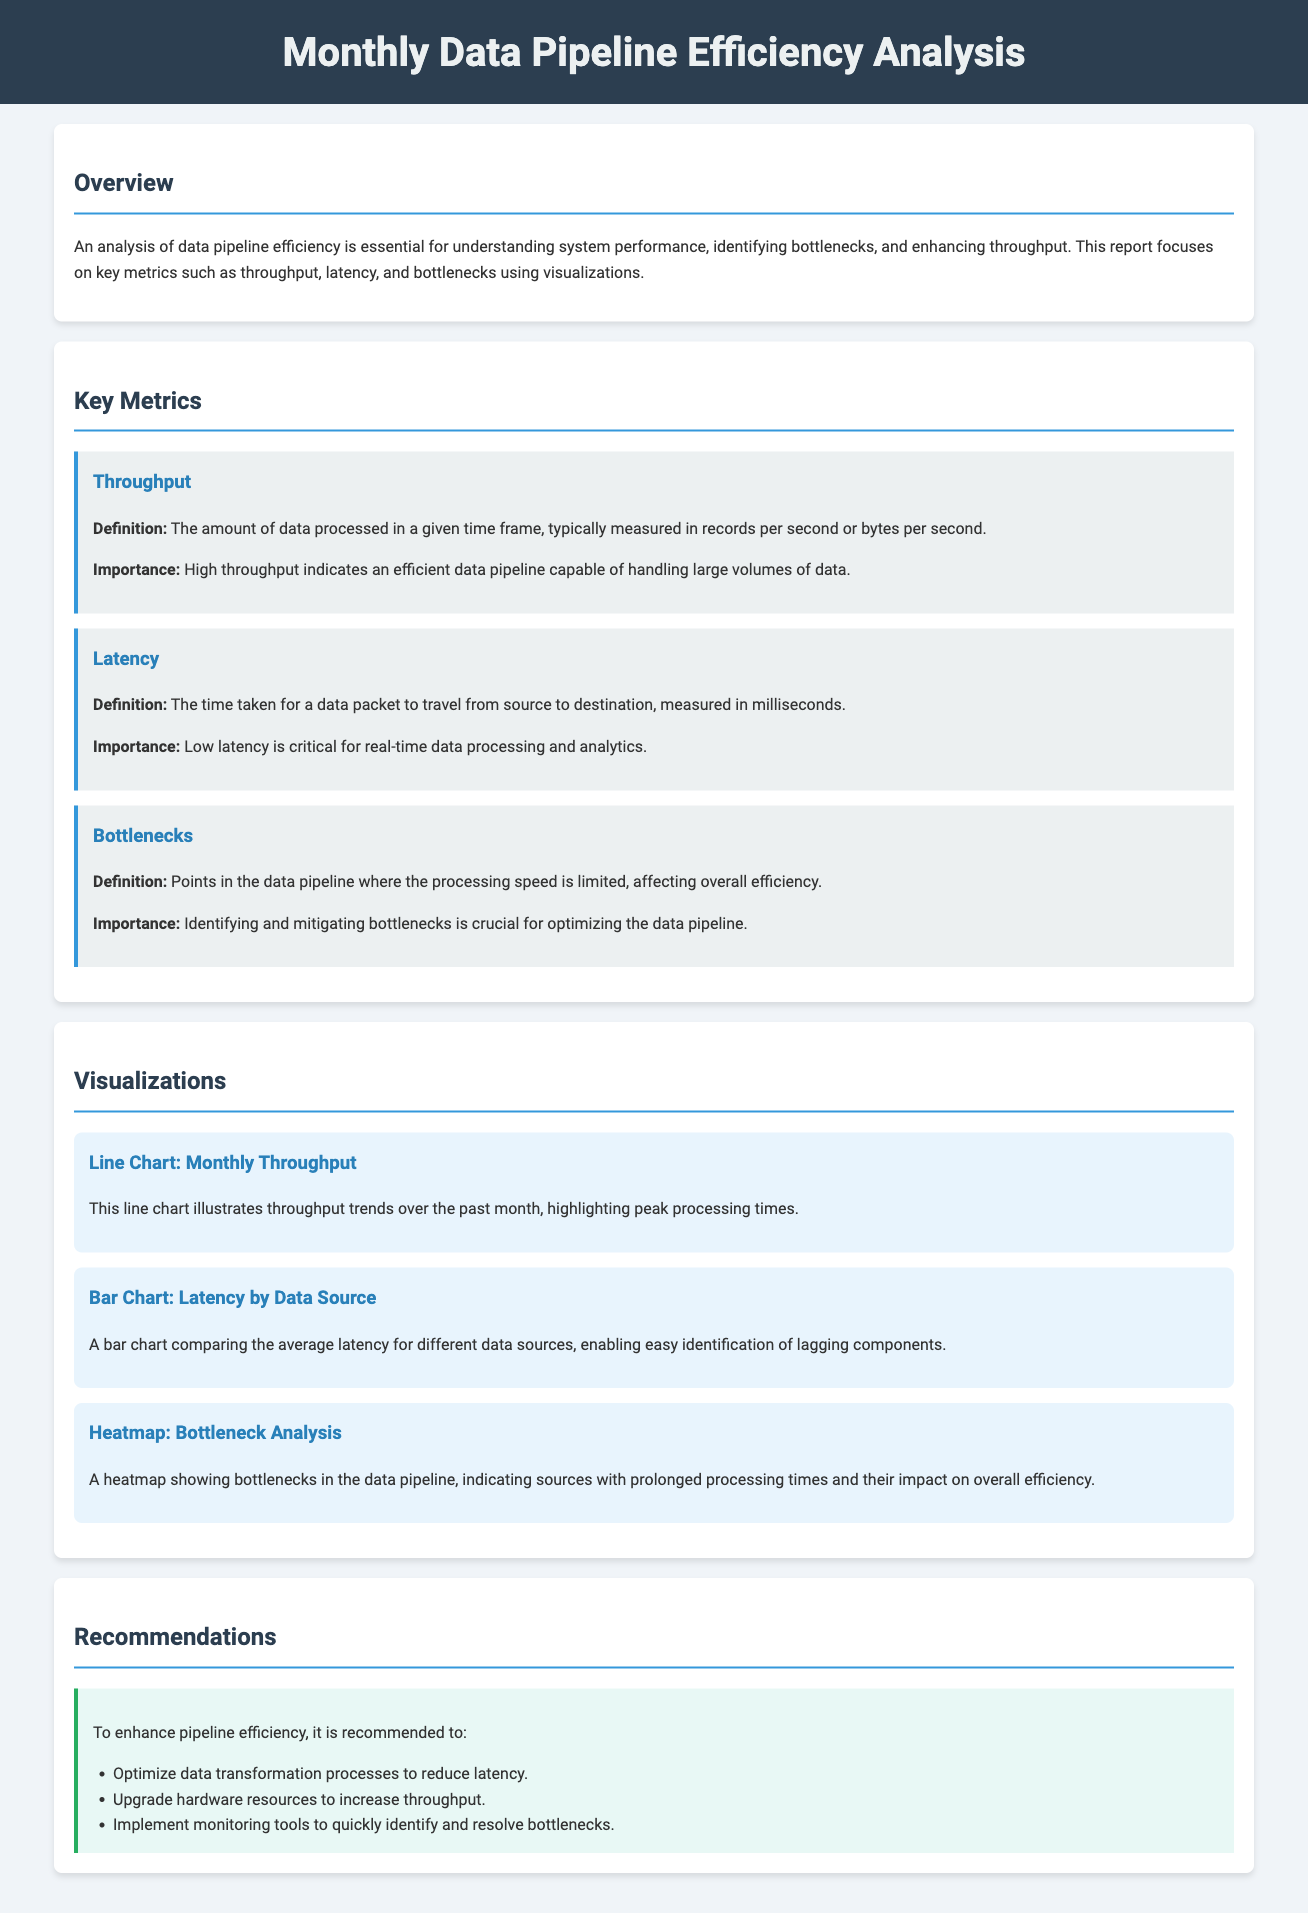What is the title of the document? The title is displayed prominently at the top of the document.
Answer: Monthly Data Pipeline Efficiency Analysis What is the definition of throughput? Throughput is defined in the document under the key metrics section.
Answer: The amount of data processed in a given time frame What does low latency indicate? Low latency is described in the latency metric section in terms of its significance.
Answer: Critical for real-time data processing What type of chart shows monthly throughput trends? The type of chart describing this visualization is specified in the visualizations section.
Answer: Line Chart How many recommendations are provided to enhance pipeline efficiency? The recommendations section lists a specific number of points for improving efficiency.
Answer: Three What is the purpose of identifying bottlenecks? The importance of identifying bottlenecks is mentioned under the bottlenecks metric.
Answer: Optimizing the data pipeline Which visualization helps identify lagging components? The document specifies which visualization is intended for this purpose.
Answer: Bar Chart What is suggested to reduce latency in the recommendations? The recommendations outline a specific action to address latency issues.
Answer: Optimize data transformation processes 